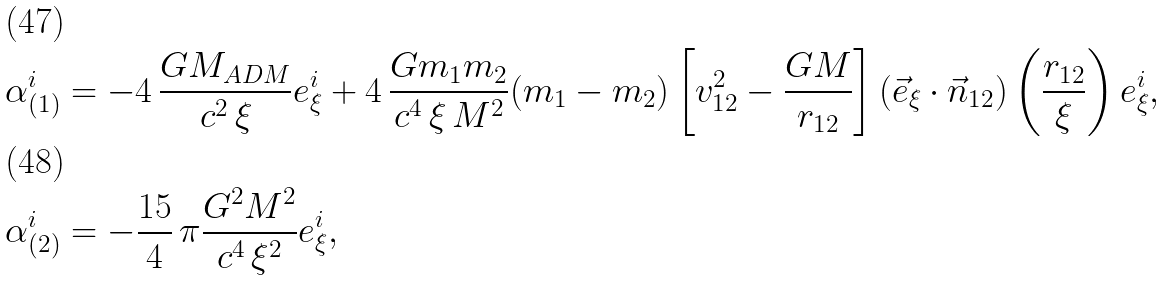Convert formula to latex. <formula><loc_0><loc_0><loc_500><loc_500>\alpha ^ { i } _ { ( 1 ) } & = - 4 \, \frac { G M _ { A D M } } { c ^ { 2 } \, \xi } e ^ { i } _ { \xi } + 4 \, \frac { G m _ { 1 } m _ { 2 } } { c ^ { 4 } \, \xi \, M ^ { 2 } } ( m _ { 1 } - m _ { 2 } ) \left [ v ^ { 2 } _ { 1 2 } - \frac { G M } { r _ { 1 2 } } \right ] ( \vec { e } _ { \xi } \cdot \vec { n } _ { 1 2 } ) \left ( \frac { r _ { 1 2 } } { \xi } \right ) e ^ { i } _ { \xi } , \\ \alpha ^ { i } _ { ( 2 ) } & = - \frac { 1 5 } { 4 } \, \pi \frac { G ^ { 2 } M ^ { 2 } } { c ^ { 4 } \, \xi ^ { 2 } } e ^ { i } _ { \xi } ,</formula> 